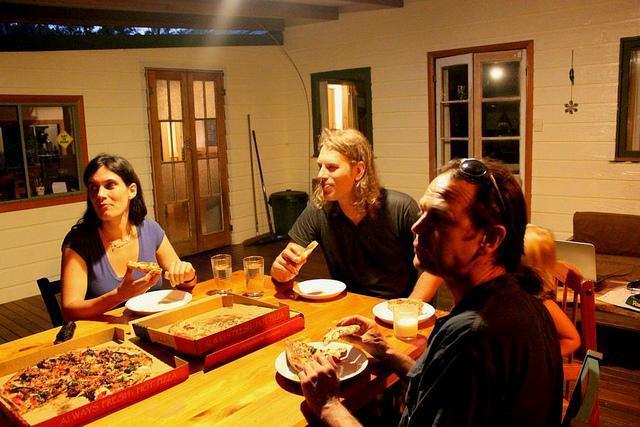How many people are in the photo?
Give a very brief answer. 4. How many pizzas are there?
Give a very brief answer. 1. How many people can be seen?
Give a very brief answer. 4. How many chairs can you see?
Give a very brief answer. 2. 